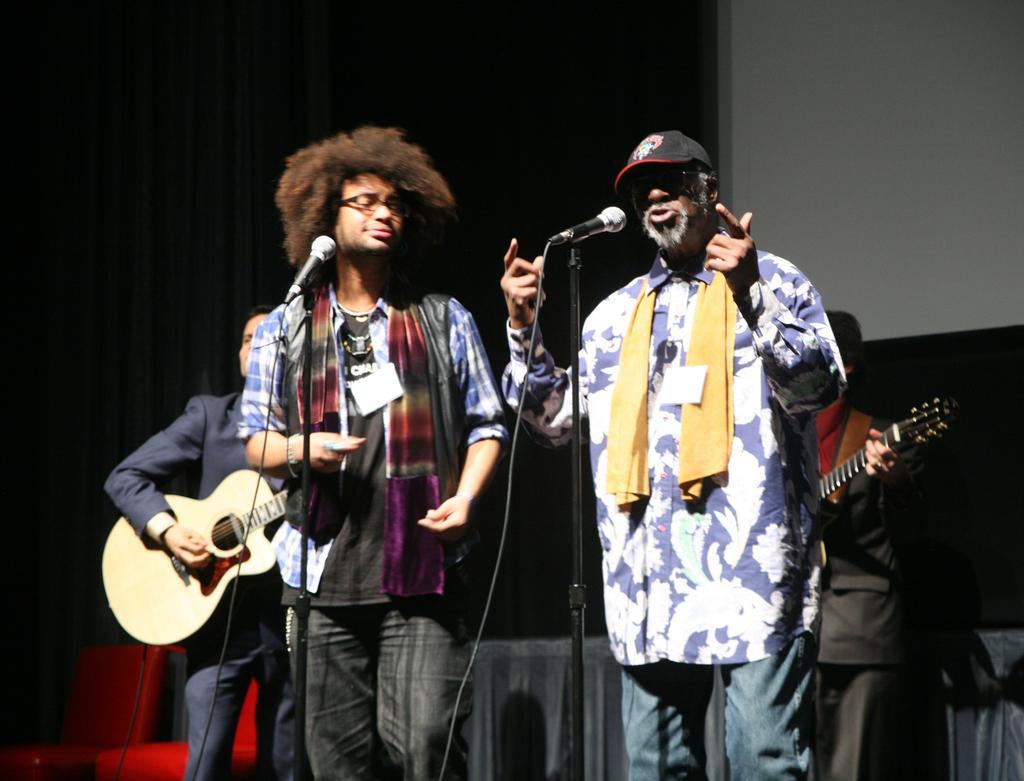Could you give a brief overview of what you see in this image? In this image, there are four persons standing and wearing colorful clothes. These two persons are standing in front of these mics. This person is wearing spectacles on his head. This person is wearing a cap on his head. These two persons are holding and playing a guitar. There are two persons behind this person. 